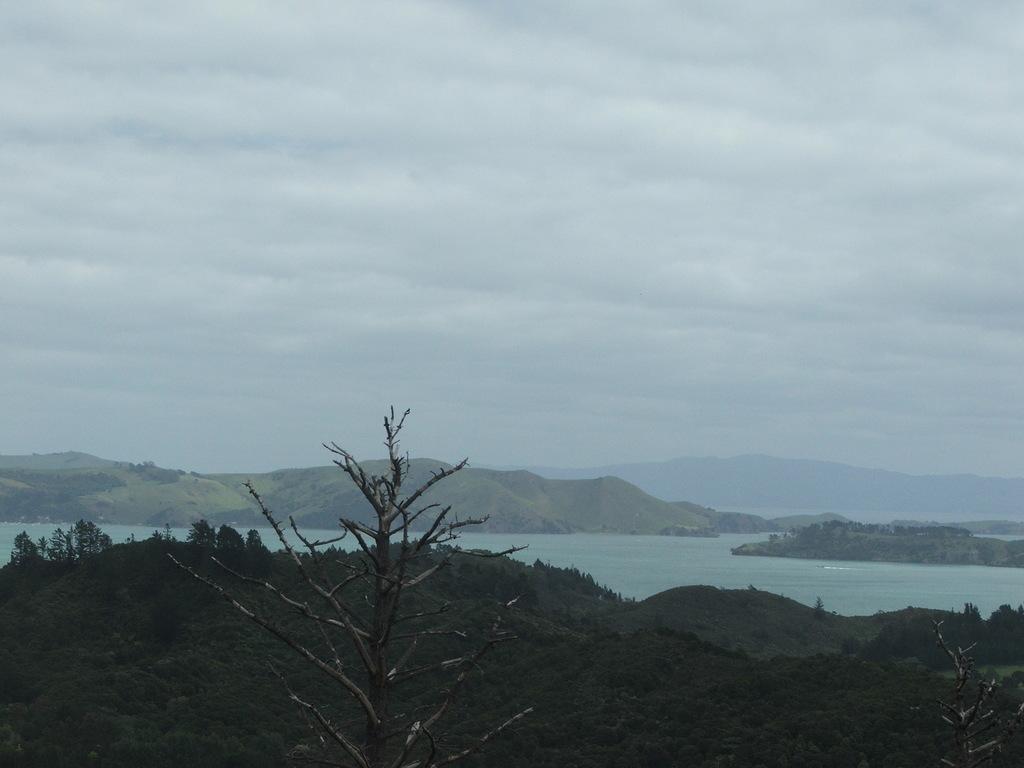Can you describe this image briefly? This image consists of trees at the bottom. There is water in the middle. There is sky at the top. There are mountains in the middle. 